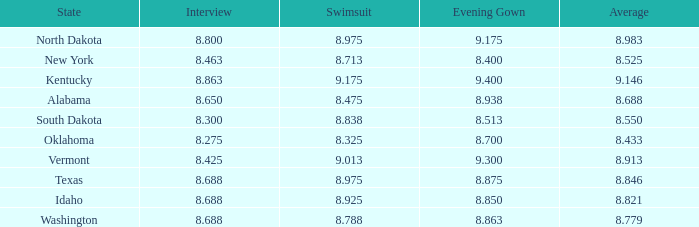For contestants from texas with evening gowns bigger than size 8.875, what is the highest average score? None. 